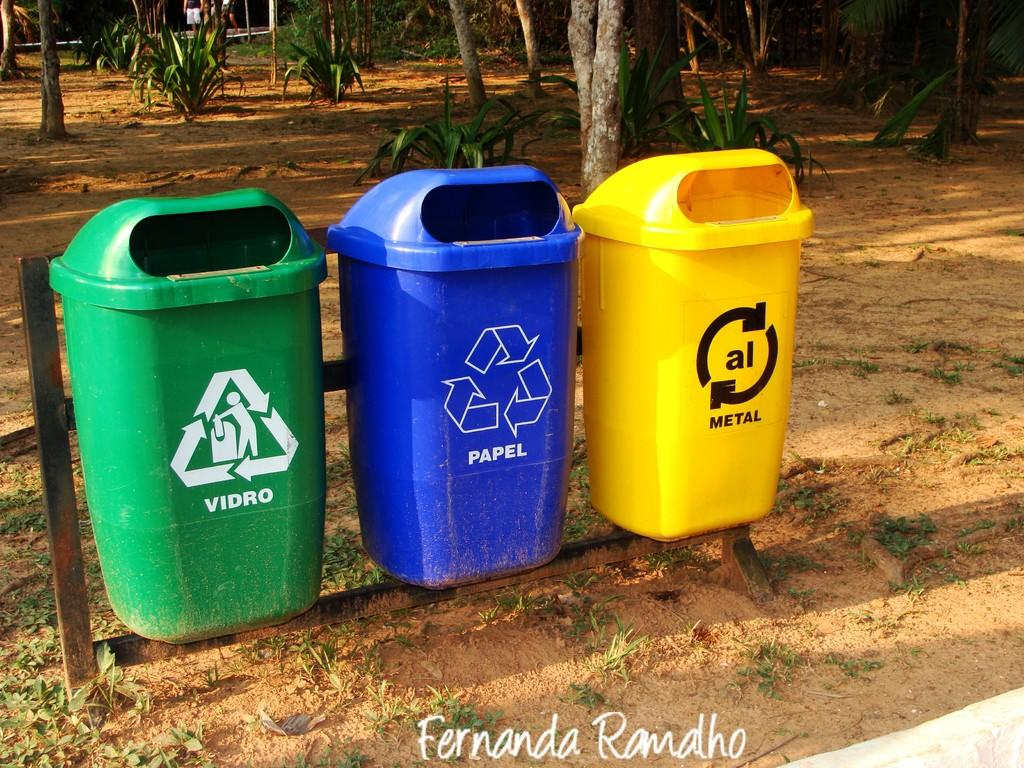<image>
Create a compact narrative representing the image presented. A blue trash can is labeled papel and the yellow trashcan is for metal. 